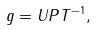Convert formula to latex. <formula><loc_0><loc_0><loc_500><loc_500>g = U P T ^ { - 1 } ,</formula> 